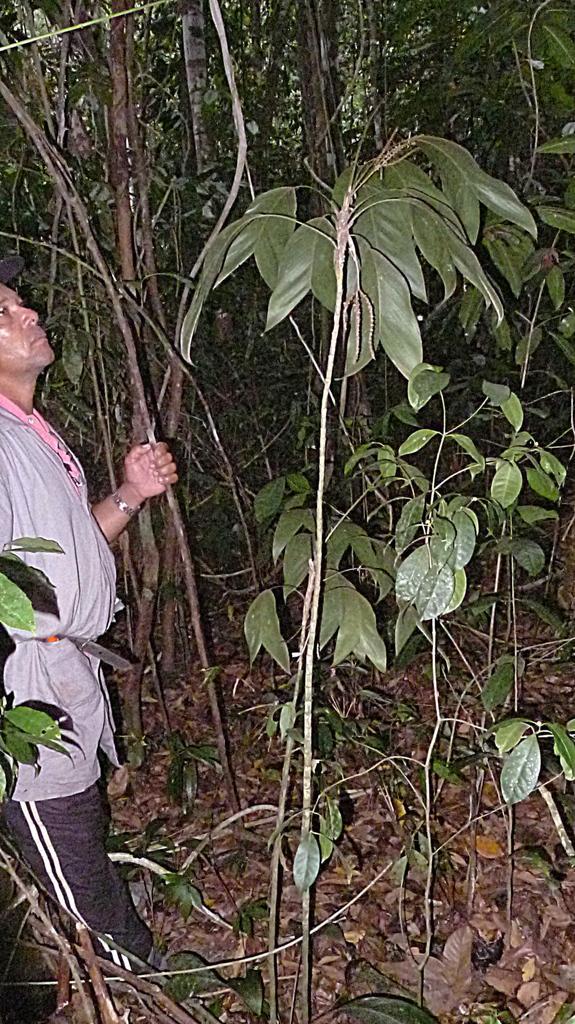Could you give a brief overview of what you see in this image? In this image I can see a man is standing, I can see he is wearing grey dress and black pant. I can also see number of trees. 